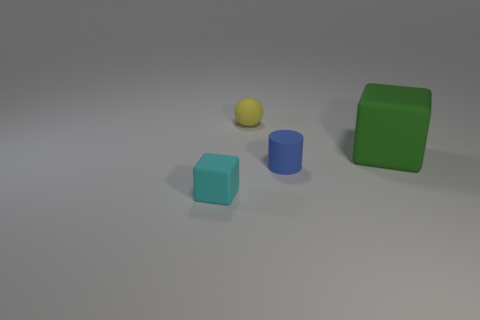Add 2 large brown metal cylinders. How many objects exist? 6 Add 1 small blue things. How many small blue things exist? 2 Subtract 1 green cubes. How many objects are left? 3 Subtract all gray balls. Subtract all brown cubes. How many balls are left? 1 Subtract all large green objects. Subtract all cyan things. How many objects are left? 2 Add 1 blocks. How many blocks are left? 3 